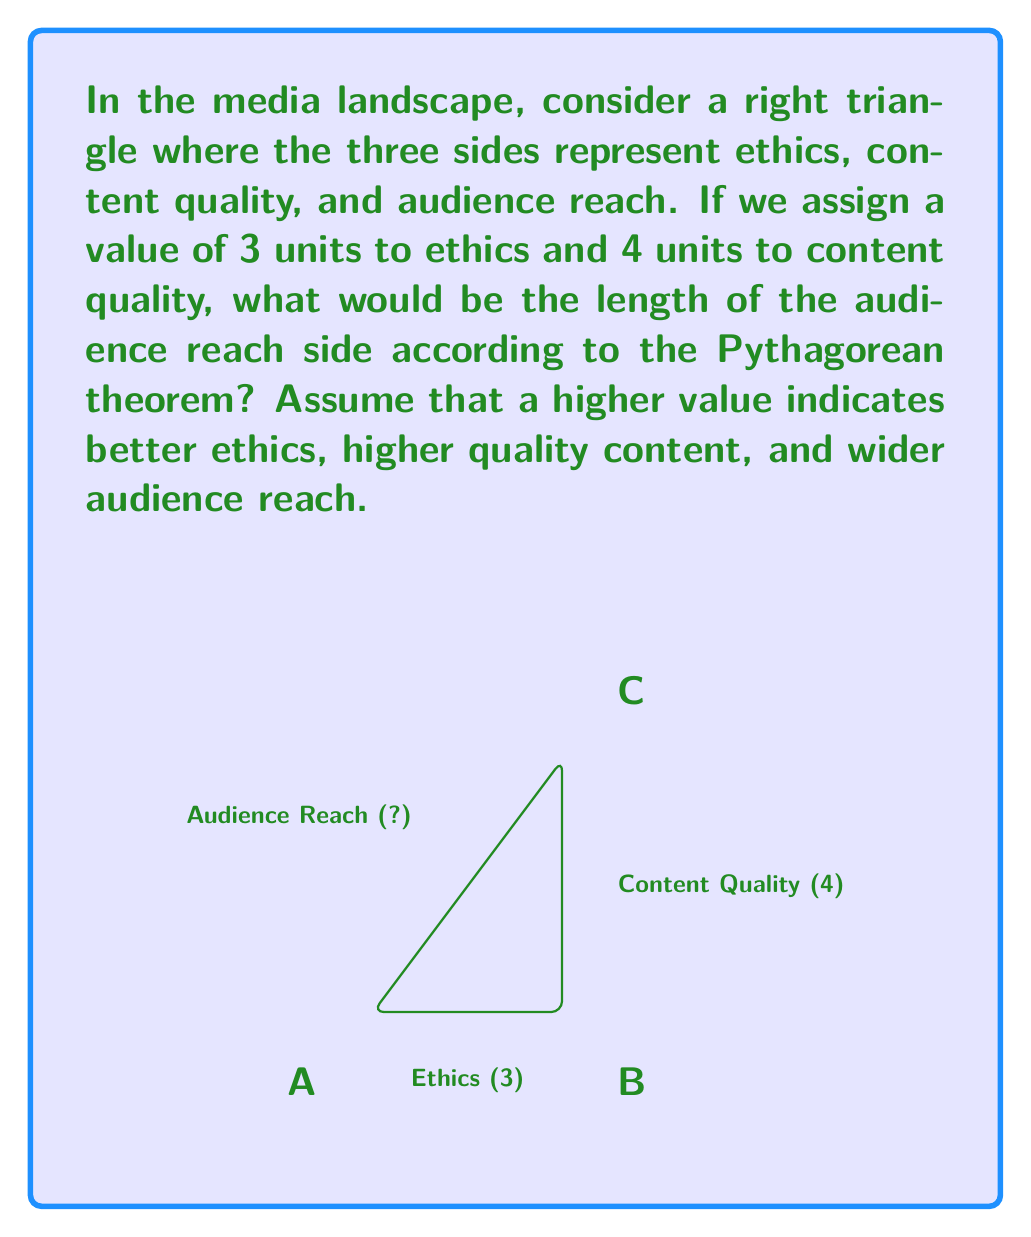Teach me how to tackle this problem. To solve this problem, we'll use the Pythagorean theorem, which states that in a right triangle, the square of the length of the hypotenuse is equal to the sum of squares of the other two sides.

Let's define our variables:
- Ethics: $a = 3$
- Content Quality: $b = 4$
- Audience Reach: $c$ (unknown)

The Pythagorean theorem is expressed as:

$$a^2 + b^2 = c^2$$

Substituting our known values:

$$3^2 + 4^2 = c^2$$

Simplifying:

$$9 + 16 = c^2$$
$$25 = c^2$$

To find $c$, we take the square root of both sides:

$$\sqrt{25} = c$$
$$5 = c$$

Therefore, the length of the audience reach side is 5 units.

This result suggests that when a media outlet maintains strong ethics (3 units) and high content quality (4 units), it can achieve a wider audience reach (5 units). The Pythagorean theorem in this context illustrates the balanced relationship between these three aspects of media production and distribution.
Answer: $c = 5$ units 